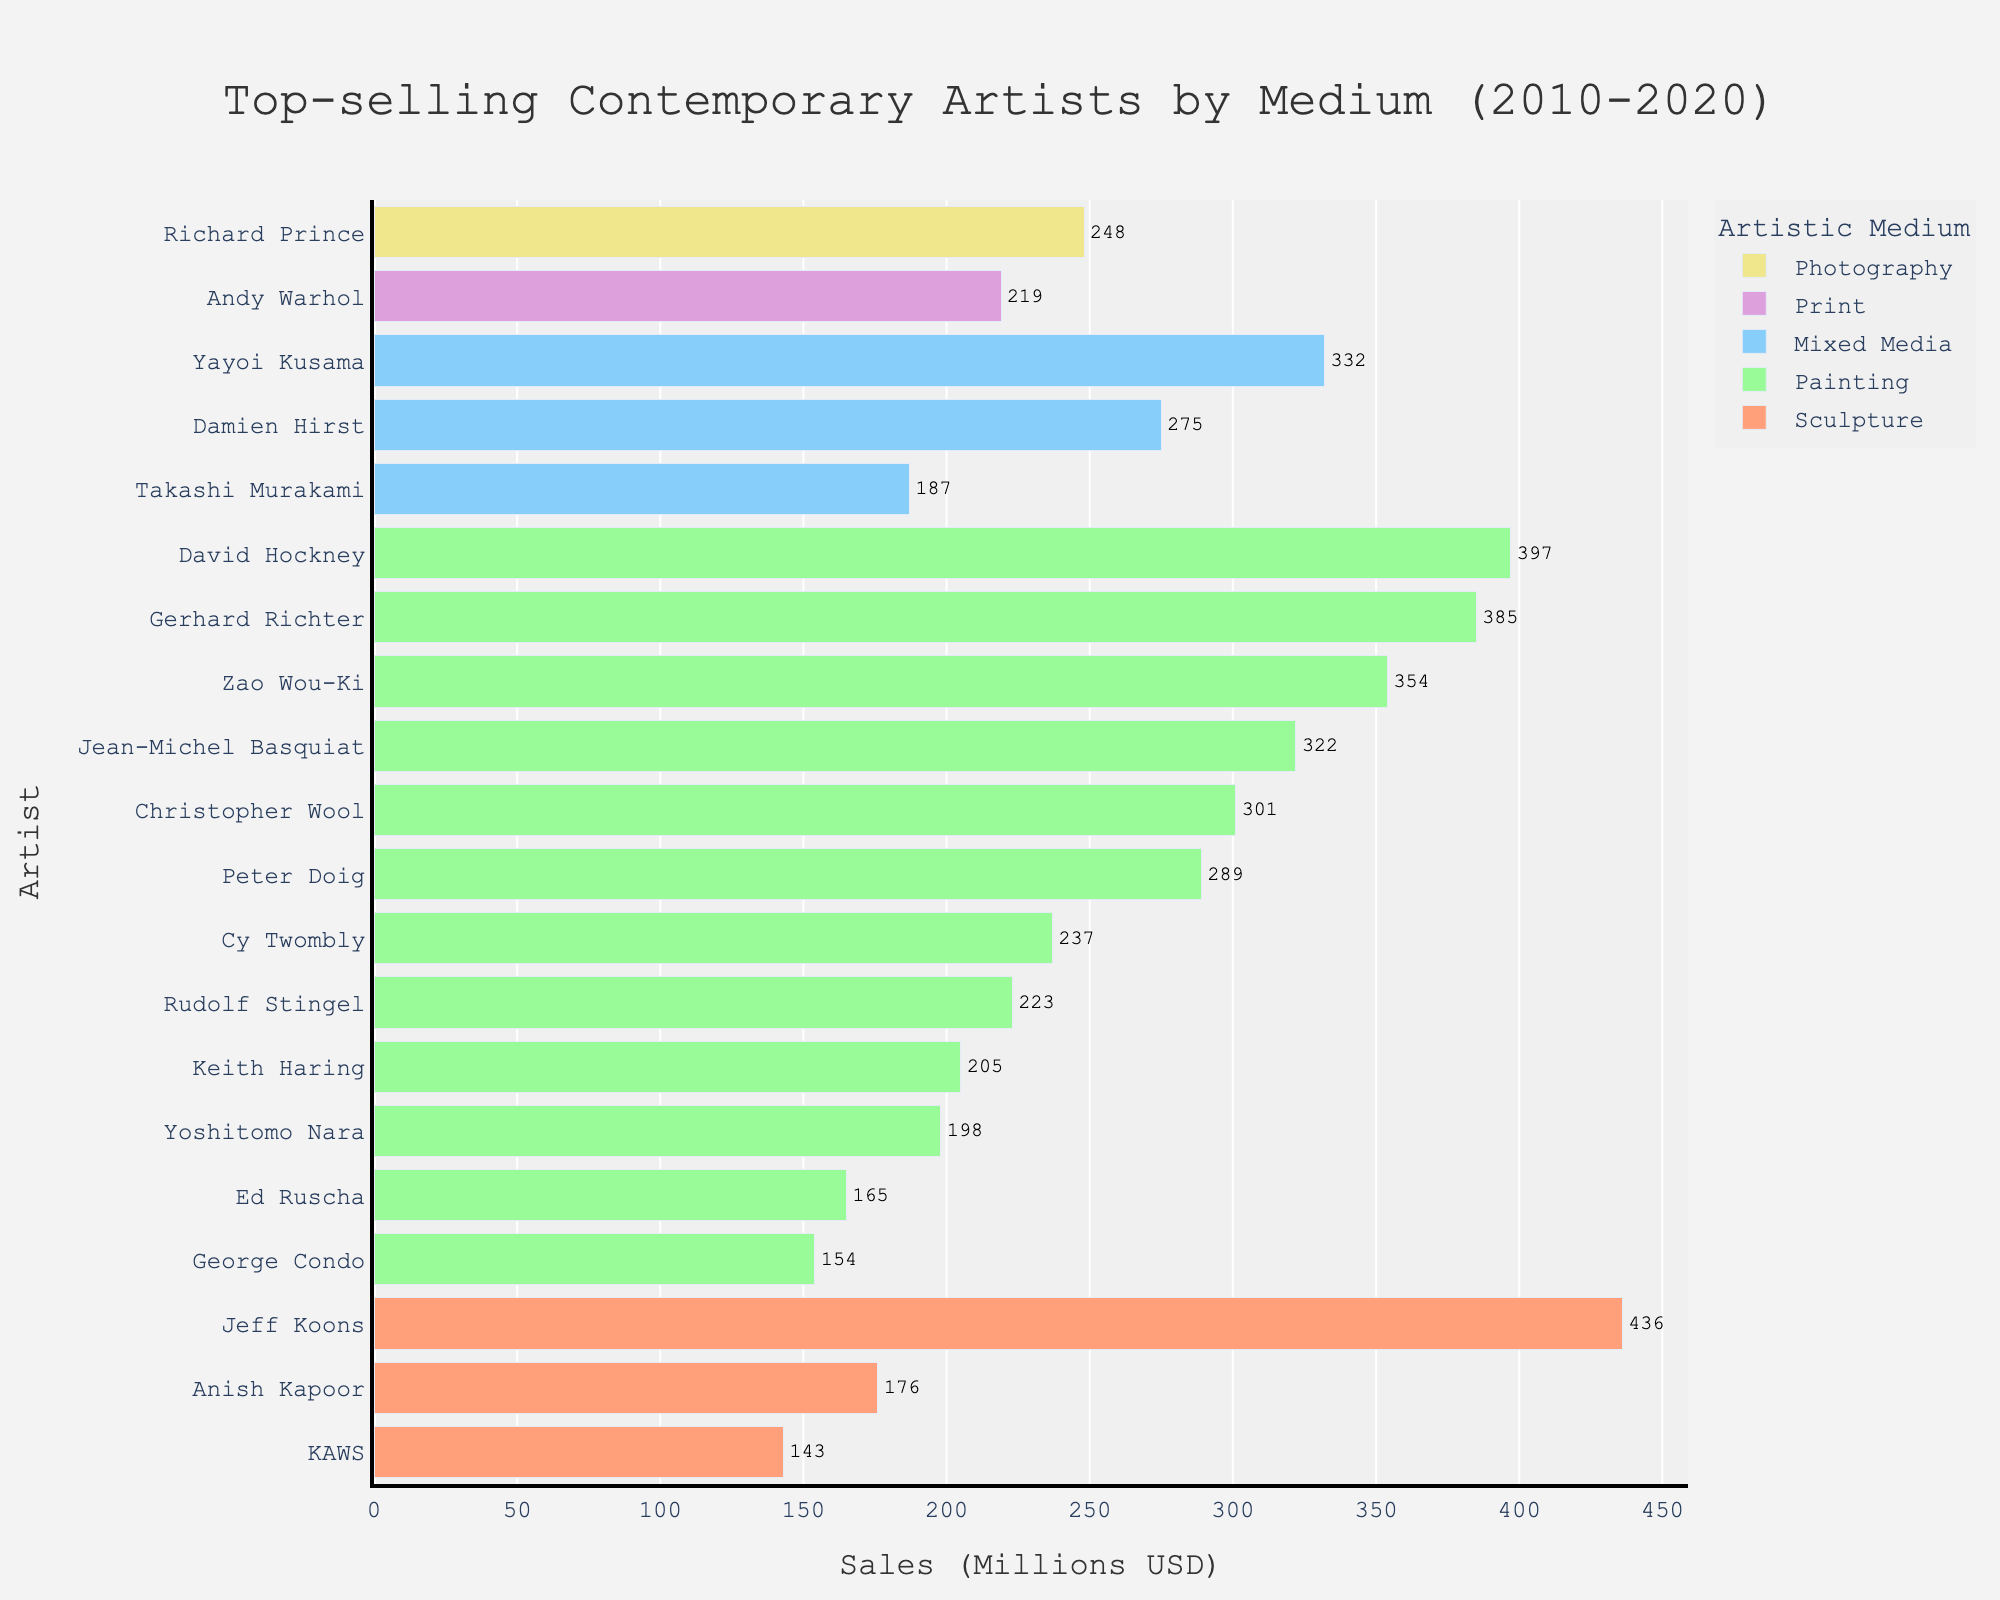Which artist has the highest sales in the Painting category? The figure shows the total sales in millions of USD for each artist by medium. In the Painting category, David Hockney has the highest sales, as his bar extends to 397 million USD, which is longer than any other bar in the Painting category.
Answer: David Hockney What is the total sales for Mixed Media artists? To find the total sales for Mixed Media artists, sum the sales values of Yayoi Kusama (332 million USD), Damien Hirst (275 million USD), and Takashi Murakami (187 million USD). So, 332 + 275 + 187 = 794 million USD.
Answer: 794 million USD Who has higher sales, Jeff Koons or KAWS, and by how much? Jeff Koons's sales are 436 million USD, and KAWS's sales are 143 million USD. To find the difference, subtract 143 from 436, resulting in 293 million USD.
Answer: Jeff Koons by 293 million USD What is the average sales value for the Painting category? First, sum the sales of all artists in the Painting category: 397 (David Hockney) + 385 (Gerhard Richter) + 354 (Zao Wou-Ki) + 322 (Jean-Michel Basquiat) + 301 (Christopher Wool) + 289 (Peter Doig) + 237 (Cy Twombly) + 223 (Rudolf Stingel) + 205 (Keith Haring) + 198 (Yoshitomo Nara) + 165 (Ed Ruscha) + 154 (George Condo) = 3530 million USD. Then, divide by the number of artists (12): 3530 / 12 = 294.17 million USD.
Answer: 294.17 million USD Which medium has the most artists listed? In the figure, count the number of artists for each medium: Painting has 12 artists, Mixed Media has 3 artists, Sculpture has 3 artists, Photography has 1 artist, and Print has 1 artist. Therefore, Painting has the most artists listed.
Answer: Painting Is the sales value of Anish Kapoor more or less than the average sales value of his medium category (Sculpture)? First, calculate the average for Sculpture. Sum the sales of Jeff Koons (436 million USD), Anish Kapoor (176 million USD), and KAWS (143 million USD): 436 + 176 + 143 = 755 million USD. Divide by 3: 755 / 3 = 251.67 million USD. Anish Kapoor's sales are 176 million USD, which is less than the average.
Answer: Less What percentage of the total sales does David Hockney contribute in the Painting category? David Hockney’s sales are 397 million USD. The total sales for the Painting category are 3530 million USD. To find the percentage, divide 397 by 3530 and multiply by 100: (397 / 3530) * 100 ≈ 11.25%.
Answer: 11.25% How many artists have sales higher than 300 million USD? From the figure, Jeff Koons, David Hockney, Gerhard Richter, Zao Wou-Ki, Yayoi Kusama, Jean-Michel Basquiat, and Christopher Wool have sales higher than 300 million USD. Counting these names gives us 7 artists.
Answer: 7 artists What is the difference in sales between the highest and lowest selling artists in the Sculpture category? The highest selling artist in Sculpture is Jeff Koons with 436 million USD, and the lowest is KAWS with 143 million USD. The difference is 436 - 143 = 293 million USD.
Answer: 293 million USD Which artist in the Photography category is listed, and what are their total sales? The figure lists Richard Prince in the Photography category, with total sales of 248 million USD.
Answer: Richard Prince, 248 million USD 